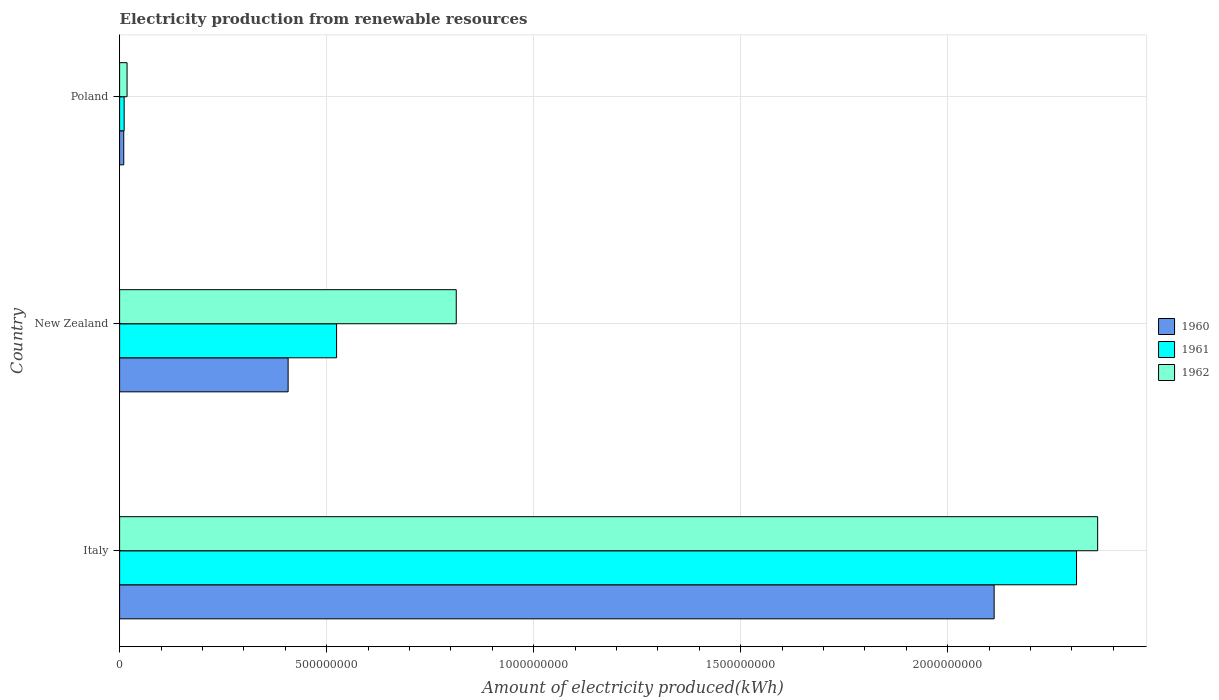How many groups of bars are there?
Your answer should be compact. 3. How many bars are there on the 1st tick from the top?
Your answer should be very brief. 3. What is the amount of electricity produced in 1961 in Italy?
Your response must be concise. 2.31e+09. Across all countries, what is the maximum amount of electricity produced in 1960?
Keep it short and to the point. 2.11e+09. Across all countries, what is the minimum amount of electricity produced in 1962?
Your answer should be compact. 1.80e+07. In which country was the amount of electricity produced in 1960 minimum?
Keep it short and to the point. Poland. What is the total amount of electricity produced in 1960 in the graph?
Your response must be concise. 2.53e+09. What is the difference between the amount of electricity produced in 1961 in New Zealand and that in Poland?
Offer a terse response. 5.13e+08. What is the difference between the amount of electricity produced in 1962 in New Zealand and the amount of electricity produced in 1961 in Poland?
Make the answer very short. 8.02e+08. What is the average amount of electricity produced in 1961 per country?
Ensure brevity in your answer.  9.49e+08. What is the difference between the amount of electricity produced in 1960 and amount of electricity produced in 1962 in New Zealand?
Offer a very short reply. -4.06e+08. What is the ratio of the amount of electricity produced in 1960 in Italy to that in Poland?
Offer a very short reply. 211.2. Is the difference between the amount of electricity produced in 1960 in New Zealand and Poland greater than the difference between the amount of electricity produced in 1962 in New Zealand and Poland?
Your answer should be very brief. No. What is the difference between the highest and the second highest amount of electricity produced in 1961?
Give a very brief answer. 1.79e+09. What is the difference between the highest and the lowest amount of electricity produced in 1961?
Your response must be concise. 2.30e+09. In how many countries, is the amount of electricity produced in 1961 greater than the average amount of electricity produced in 1961 taken over all countries?
Ensure brevity in your answer.  1. What is the difference between two consecutive major ticks on the X-axis?
Keep it short and to the point. 5.00e+08. Are the values on the major ticks of X-axis written in scientific E-notation?
Provide a short and direct response. No. Does the graph contain any zero values?
Provide a short and direct response. No. Where does the legend appear in the graph?
Give a very brief answer. Center right. What is the title of the graph?
Keep it short and to the point. Electricity production from renewable resources. What is the label or title of the X-axis?
Ensure brevity in your answer.  Amount of electricity produced(kWh). What is the Amount of electricity produced(kWh) in 1960 in Italy?
Your answer should be very brief. 2.11e+09. What is the Amount of electricity produced(kWh) in 1961 in Italy?
Give a very brief answer. 2.31e+09. What is the Amount of electricity produced(kWh) in 1962 in Italy?
Your answer should be compact. 2.36e+09. What is the Amount of electricity produced(kWh) in 1960 in New Zealand?
Offer a terse response. 4.07e+08. What is the Amount of electricity produced(kWh) of 1961 in New Zealand?
Make the answer very short. 5.24e+08. What is the Amount of electricity produced(kWh) in 1962 in New Zealand?
Provide a short and direct response. 8.13e+08. What is the Amount of electricity produced(kWh) in 1961 in Poland?
Your answer should be compact. 1.10e+07. What is the Amount of electricity produced(kWh) in 1962 in Poland?
Give a very brief answer. 1.80e+07. Across all countries, what is the maximum Amount of electricity produced(kWh) in 1960?
Your response must be concise. 2.11e+09. Across all countries, what is the maximum Amount of electricity produced(kWh) of 1961?
Provide a short and direct response. 2.31e+09. Across all countries, what is the maximum Amount of electricity produced(kWh) of 1962?
Offer a very short reply. 2.36e+09. Across all countries, what is the minimum Amount of electricity produced(kWh) in 1960?
Offer a very short reply. 1.00e+07. Across all countries, what is the minimum Amount of electricity produced(kWh) of 1961?
Your answer should be compact. 1.10e+07. Across all countries, what is the minimum Amount of electricity produced(kWh) of 1962?
Your response must be concise. 1.80e+07. What is the total Amount of electricity produced(kWh) in 1960 in the graph?
Provide a succinct answer. 2.53e+09. What is the total Amount of electricity produced(kWh) of 1961 in the graph?
Offer a terse response. 2.85e+09. What is the total Amount of electricity produced(kWh) in 1962 in the graph?
Provide a succinct answer. 3.19e+09. What is the difference between the Amount of electricity produced(kWh) in 1960 in Italy and that in New Zealand?
Provide a succinct answer. 1.70e+09. What is the difference between the Amount of electricity produced(kWh) in 1961 in Italy and that in New Zealand?
Give a very brief answer. 1.79e+09. What is the difference between the Amount of electricity produced(kWh) in 1962 in Italy and that in New Zealand?
Your answer should be compact. 1.55e+09. What is the difference between the Amount of electricity produced(kWh) of 1960 in Italy and that in Poland?
Offer a terse response. 2.10e+09. What is the difference between the Amount of electricity produced(kWh) in 1961 in Italy and that in Poland?
Your answer should be very brief. 2.30e+09. What is the difference between the Amount of electricity produced(kWh) of 1962 in Italy and that in Poland?
Keep it short and to the point. 2.34e+09. What is the difference between the Amount of electricity produced(kWh) in 1960 in New Zealand and that in Poland?
Offer a terse response. 3.97e+08. What is the difference between the Amount of electricity produced(kWh) in 1961 in New Zealand and that in Poland?
Make the answer very short. 5.13e+08. What is the difference between the Amount of electricity produced(kWh) of 1962 in New Zealand and that in Poland?
Ensure brevity in your answer.  7.95e+08. What is the difference between the Amount of electricity produced(kWh) in 1960 in Italy and the Amount of electricity produced(kWh) in 1961 in New Zealand?
Provide a short and direct response. 1.59e+09. What is the difference between the Amount of electricity produced(kWh) of 1960 in Italy and the Amount of electricity produced(kWh) of 1962 in New Zealand?
Your answer should be very brief. 1.30e+09. What is the difference between the Amount of electricity produced(kWh) in 1961 in Italy and the Amount of electricity produced(kWh) in 1962 in New Zealand?
Offer a terse response. 1.50e+09. What is the difference between the Amount of electricity produced(kWh) of 1960 in Italy and the Amount of electricity produced(kWh) of 1961 in Poland?
Provide a succinct answer. 2.10e+09. What is the difference between the Amount of electricity produced(kWh) in 1960 in Italy and the Amount of electricity produced(kWh) in 1962 in Poland?
Your response must be concise. 2.09e+09. What is the difference between the Amount of electricity produced(kWh) in 1961 in Italy and the Amount of electricity produced(kWh) in 1962 in Poland?
Ensure brevity in your answer.  2.29e+09. What is the difference between the Amount of electricity produced(kWh) in 1960 in New Zealand and the Amount of electricity produced(kWh) in 1961 in Poland?
Provide a short and direct response. 3.96e+08. What is the difference between the Amount of electricity produced(kWh) of 1960 in New Zealand and the Amount of electricity produced(kWh) of 1962 in Poland?
Make the answer very short. 3.89e+08. What is the difference between the Amount of electricity produced(kWh) of 1961 in New Zealand and the Amount of electricity produced(kWh) of 1962 in Poland?
Provide a succinct answer. 5.06e+08. What is the average Amount of electricity produced(kWh) of 1960 per country?
Your answer should be compact. 8.43e+08. What is the average Amount of electricity produced(kWh) of 1961 per country?
Give a very brief answer. 9.49e+08. What is the average Amount of electricity produced(kWh) in 1962 per country?
Offer a terse response. 1.06e+09. What is the difference between the Amount of electricity produced(kWh) of 1960 and Amount of electricity produced(kWh) of 1961 in Italy?
Make the answer very short. -1.99e+08. What is the difference between the Amount of electricity produced(kWh) in 1960 and Amount of electricity produced(kWh) in 1962 in Italy?
Offer a terse response. -2.50e+08. What is the difference between the Amount of electricity produced(kWh) in 1961 and Amount of electricity produced(kWh) in 1962 in Italy?
Provide a succinct answer. -5.10e+07. What is the difference between the Amount of electricity produced(kWh) in 1960 and Amount of electricity produced(kWh) in 1961 in New Zealand?
Provide a short and direct response. -1.17e+08. What is the difference between the Amount of electricity produced(kWh) of 1960 and Amount of electricity produced(kWh) of 1962 in New Zealand?
Offer a terse response. -4.06e+08. What is the difference between the Amount of electricity produced(kWh) of 1961 and Amount of electricity produced(kWh) of 1962 in New Zealand?
Offer a very short reply. -2.89e+08. What is the difference between the Amount of electricity produced(kWh) in 1960 and Amount of electricity produced(kWh) in 1962 in Poland?
Keep it short and to the point. -8.00e+06. What is the difference between the Amount of electricity produced(kWh) of 1961 and Amount of electricity produced(kWh) of 1962 in Poland?
Provide a short and direct response. -7.00e+06. What is the ratio of the Amount of electricity produced(kWh) in 1960 in Italy to that in New Zealand?
Your response must be concise. 5.19. What is the ratio of the Amount of electricity produced(kWh) of 1961 in Italy to that in New Zealand?
Ensure brevity in your answer.  4.41. What is the ratio of the Amount of electricity produced(kWh) in 1962 in Italy to that in New Zealand?
Make the answer very short. 2.91. What is the ratio of the Amount of electricity produced(kWh) in 1960 in Italy to that in Poland?
Make the answer very short. 211.2. What is the ratio of the Amount of electricity produced(kWh) in 1961 in Italy to that in Poland?
Offer a very short reply. 210.09. What is the ratio of the Amount of electricity produced(kWh) in 1962 in Italy to that in Poland?
Make the answer very short. 131.22. What is the ratio of the Amount of electricity produced(kWh) in 1960 in New Zealand to that in Poland?
Provide a succinct answer. 40.7. What is the ratio of the Amount of electricity produced(kWh) of 1961 in New Zealand to that in Poland?
Provide a short and direct response. 47.64. What is the ratio of the Amount of electricity produced(kWh) of 1962 in New Zealand to that in Poland?
Give a very brief answer. 45.17. What is the difference between the highest and the second highest Amount of electricity produced(kWh) of 1960?
Your response must be concise. 1.70e+09. What is the difference between the highest and the second highest Amount of electricity produced(kWh) in 1961?
Make the answer very short. 1.79e+09. What is the difference between the highest and the second highest Amount of electricity produced(kWh) in 1962?
Provide a succinct answer. 1.55e+09. What is the difference between the highest and the lowest Amount of electricity produced(kWh) of 1960?
Give a very brief answer. 2.10e+09. What is the difference between the highest and the lowest Amount of electricity produced(kWh) in 1961?
Your response must be concise. 2.30e+09. What is the difference between the highest and the lowest Amount of electricity produced(kWh) of 1962?
Make the answer very short. 2.34e+09. 